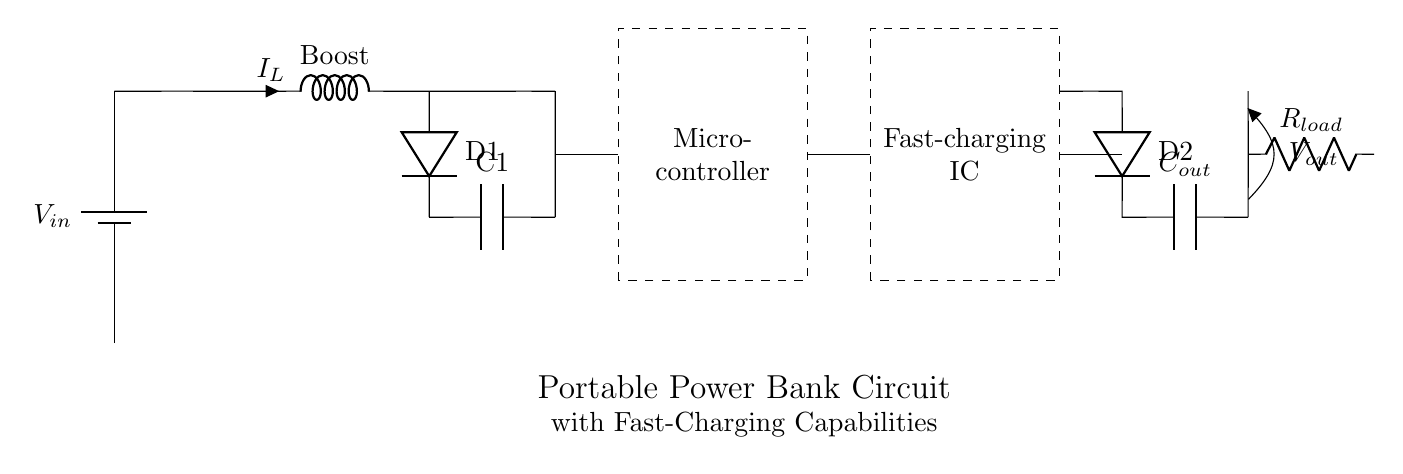What is the voltage source in this circuit? The voltage source is labeled as V in on the battery symbol at the left of the circuit, indicating the input voltage that powers the circuit.
Answer: V in What does the component labeled "Boost" do? The Boost component indicates a boost converter, which increases the input voltage to a higher output voltage suitable for charging mobile devices.
Answer: Increases voltage What type of component is D1 in the circuit? D1 is represented as a diode, which allows current to flow in one direction and blocks it in the reverse direction, ensuring proper operation of the circuit.
Answer: Diode How many capacitors are present in the circuit? There are two capacitors in the circuit, labeled C1 and C out, indicated by the capacitor symbols in the diagram.
Answer: Two What is the purpose of the fast-charging IC? The fast-charging IC regulates the charging process to allow rapid charging of connected mobile devices, optimizing power delivery from the battery.
Answer: Rapid charging What is the load component labeled R load? R load is a resistor that represents the load connected to the output, demonstrating how the circuit will be used during operation, drawing current from the stored energy.
Answer: Resistor Which components are connected to the microcontroller? The connections to the microcontroller include the inductor from the boost converter and signals to and from the fast-charging IC, indicating its control function.
Answer: Inductor and IC connections 